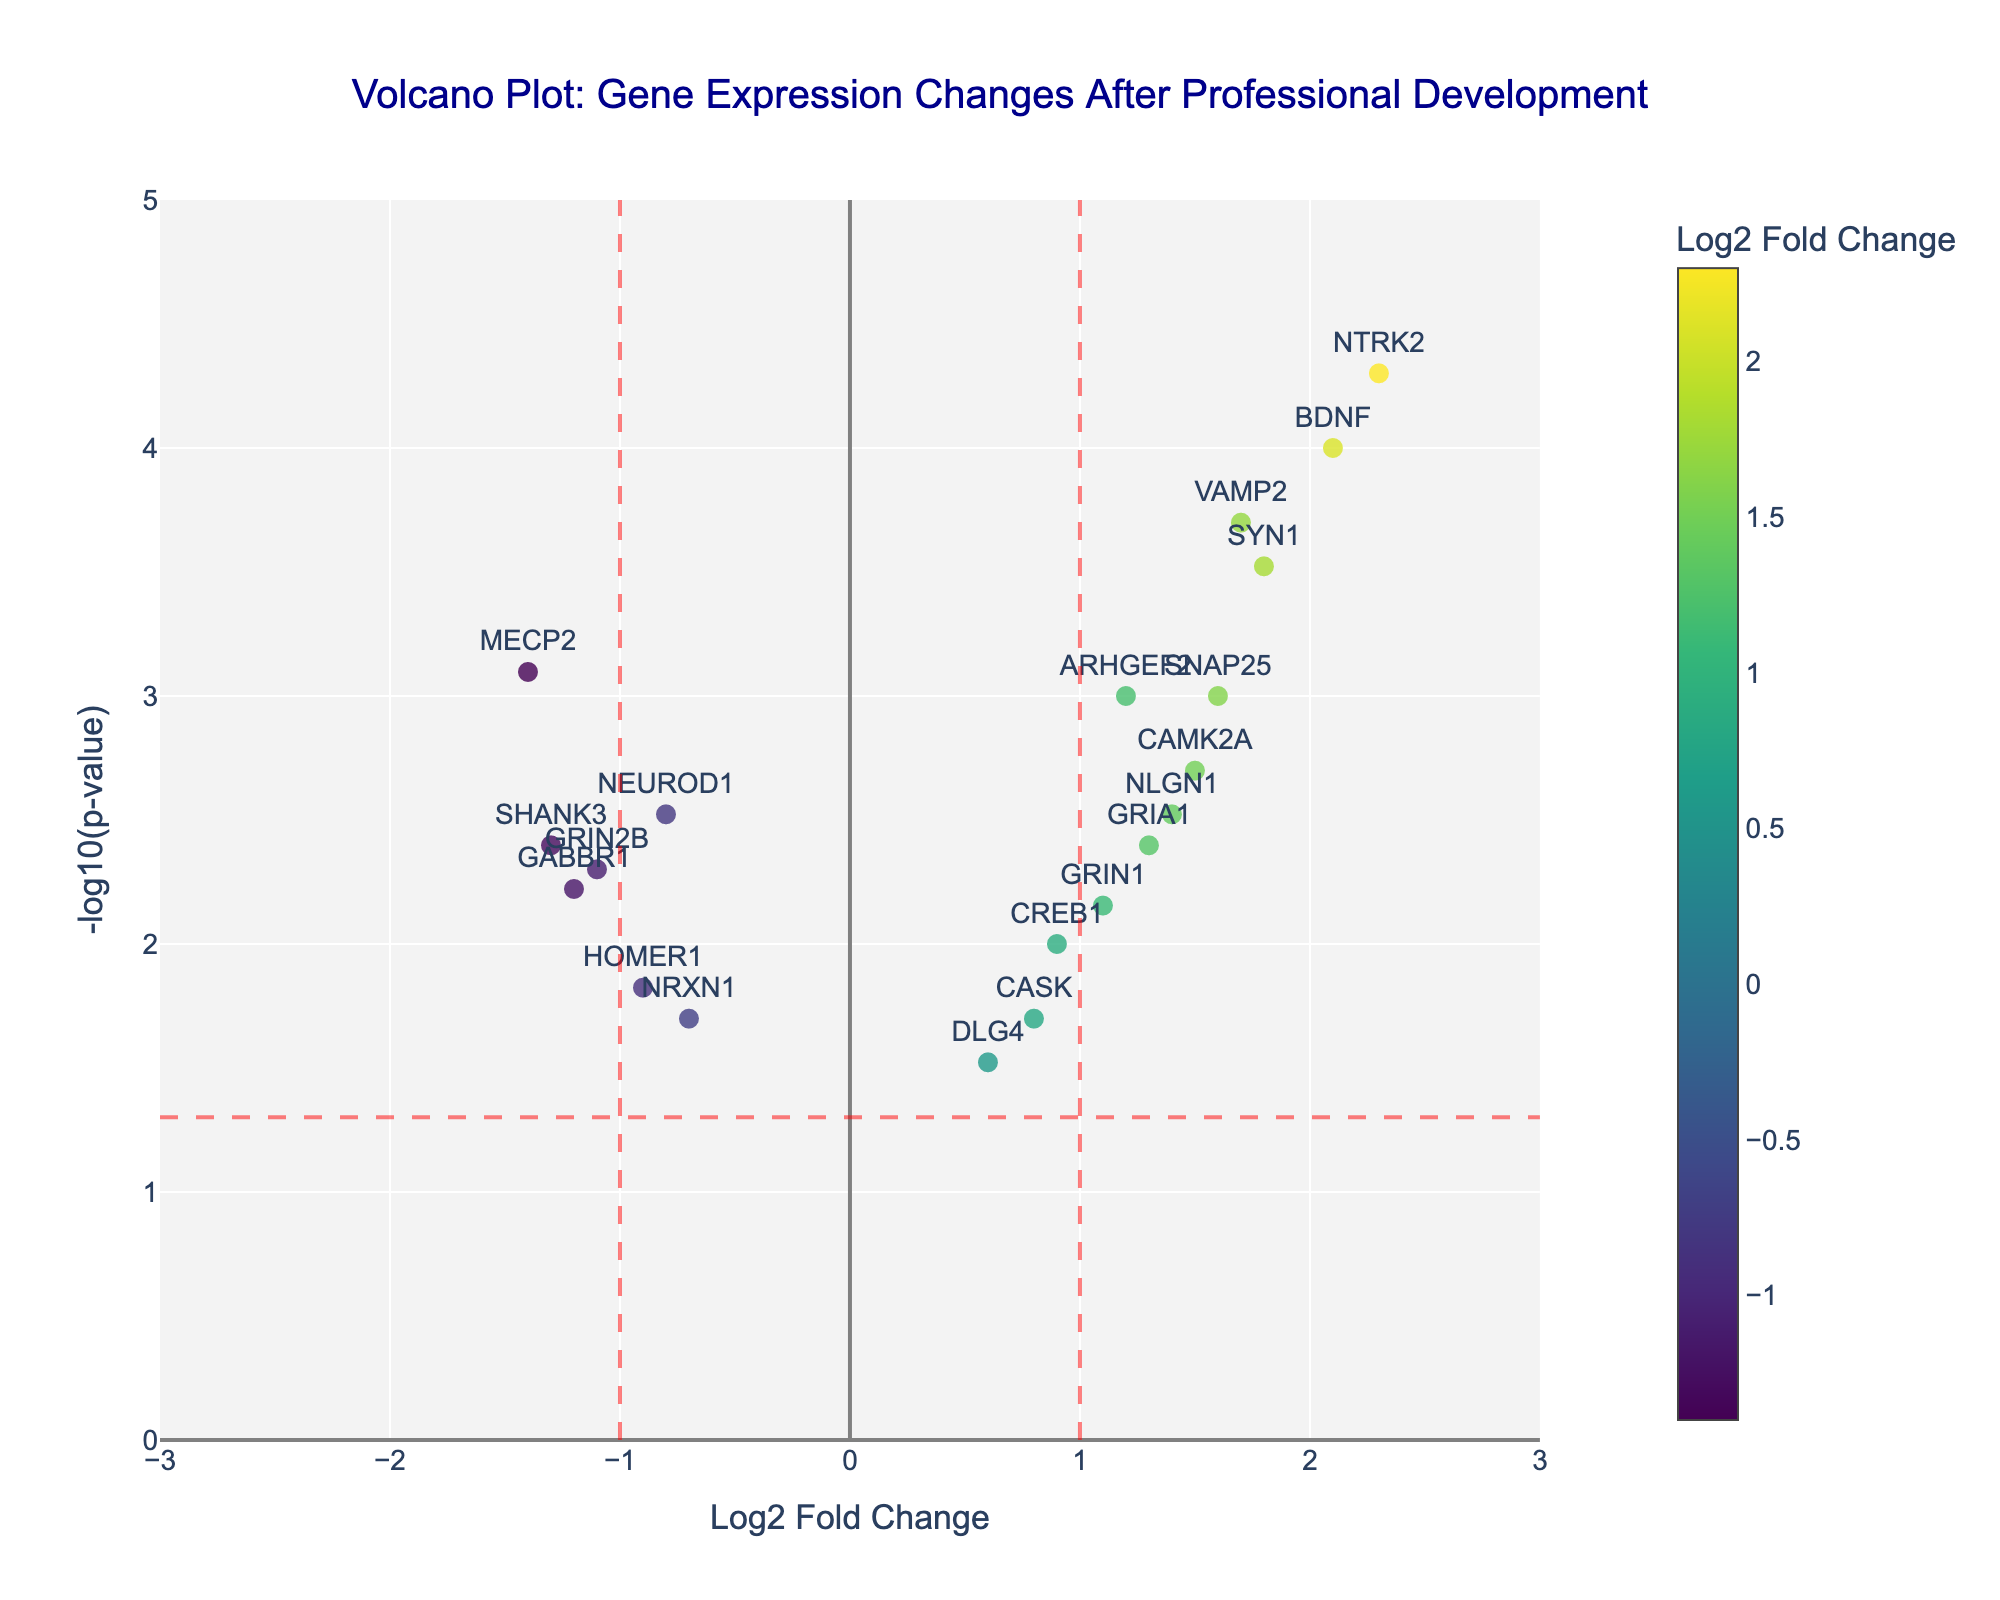Which gene has the highest log2 fold change? From the plot, the highest point along the x-axis indicates the greatest log2 fold change. Look for the gene label corresponding to the furthest right point on the x-axis.
Answer: NTRK2 What is the p-value for the BDNF gene? To find the p-value for BDNF, locate BDNF in the plot and read the hover text or use the y-axis value (-log10(p-value)) and convert it back to the original p-value.
Answer: 0.0001 How many genes have a log2 fold change greater than 1 and a p-value less than 0.05? Count the number of data points to the right of the vertical line at x=1 and above the horizontal line at y=-log10(0.05). Each point represents a gene meeting the criteria.
Answer: 7 Which genes have a significant p-value but a negative log2 fold change? Significant p-values are shown above the horizontal line at y=-log10(0.05), and negative log2 fold change values are to the left of the vertical line at x=0. Look for points in the top-left quadrant.
Answer: NEUROD1, GRIN2B, MECP2, HOMER1, GABBR1, SHANK3 What does the color scale in the plot represent? The color scale along the markers represents the log2 fold change values. Darker colors indicate more extreme fold changes.
Answer: log2 fold change Which gene is closest to having no change (log2 fold change near 0) but is still significant? Look for the gene closest to x=0 but above the y=-log10(0.05) horizontal line. This gene has minimal change but a significant p-value.
Answer: DLG4 Is there a gene with both a very high log2 fold change and a very low p-value? Check for data points furthest to the right and at the highest position (indicating low p-value). Correspond to the hover text or labels.
Answer: NTRK2 Which genes are downregulated significantly (log2 fold change < -1, p-value < 0.05)? These genes fall to the left of x=-1 and above y=-log10(0.05). Locate the corresponding points and labels.
Answer: GRIN2B, MECP2, GABBR1, SHANK3 What is the median log2 fold change of all genes on the plot? Order all log2 fold change values and find the middle one. This involves sorting and detecting the central value.
Answer: 0.9 